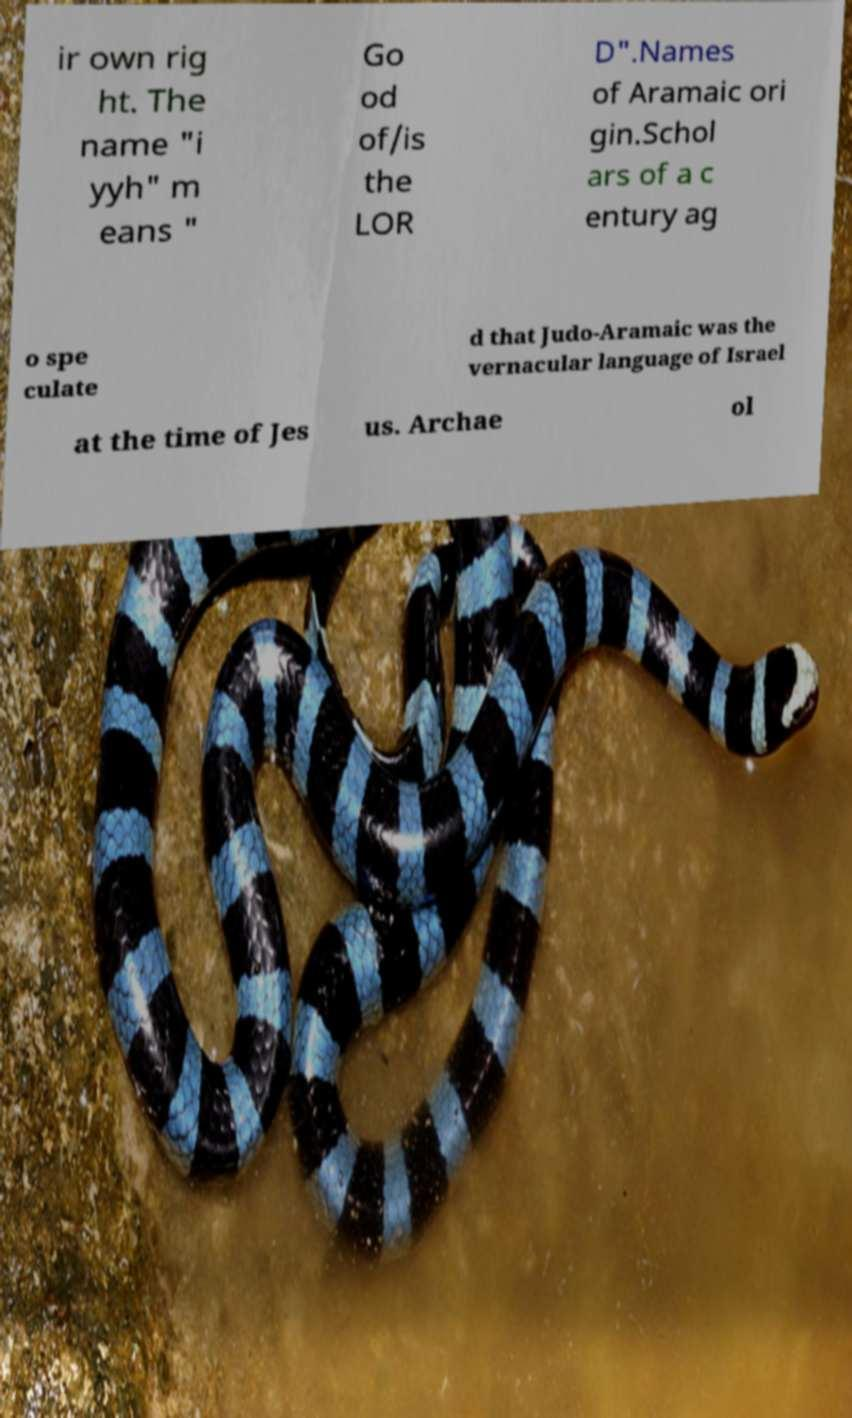Please read and relay the text visible in this image. What does it say? ir own rig ht. The name "i yyh" m eans " Go od of/is the LOR D".Names of Aramaic ori gin.Schol ars of a c entury ag o spe culate d that Judo-Aramaic was the vernacular language of Israel at the time of Jes us. Archae ol 